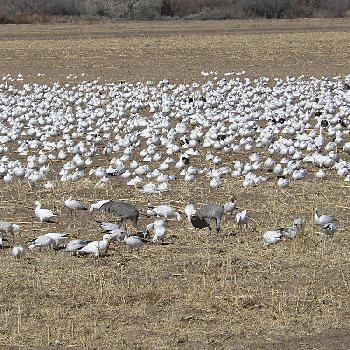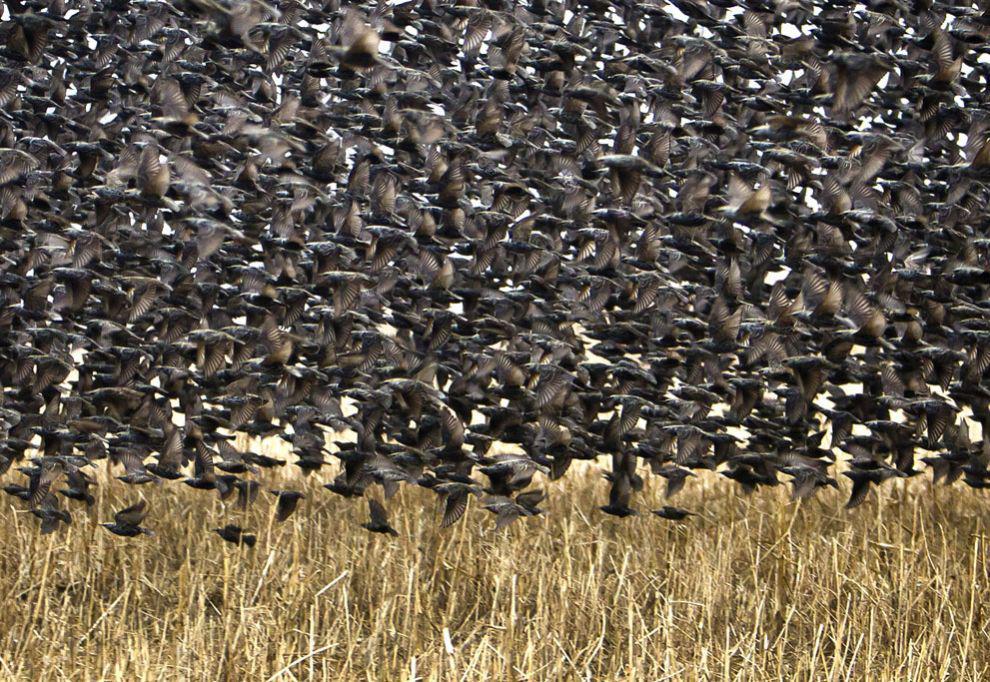The first image is the image on the left, the second image is the image on the right. Examine the images to the left and right. Is the description "The left image includes a body of water with some birds in the water." accurate? Answer yes or no. No. The first image is the image on the left, the second image is the image on the right. For the images displayed, is the sentence "There are at least 100 white bird sitting on the ground with at least 2 gray crane walking across the field." factually correct? Answer yes or no. Yes. 